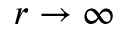Convert formula to latex. <formula><loc_0><loc_0><loc_500><loc_500>r \to \infty</formula> 